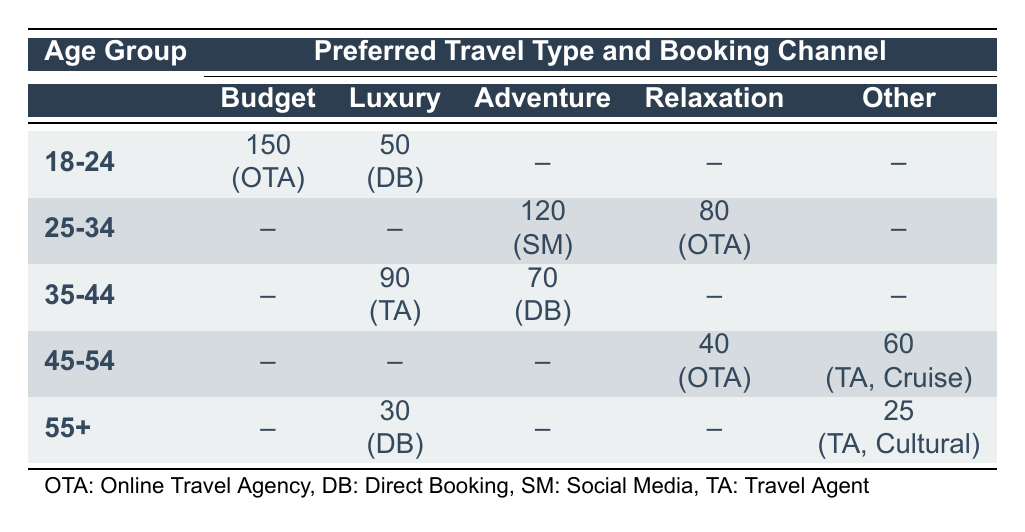What is the preferred travel type of the 18-24 age group using an online travel agency? The table shows that the 18-24 age group has a count of 150 for the Budget travel type under the Online Travel Agency booking channel.
Answer: Budget How many people aged 35-44 prefer Luxury travel and use a travel agent? The table indicates that for the 35-44 age group, 90 individuals prefer Luxury travel, and they book through a Travel Agent.
Answer: 90 Is there any age group that prefers Adventure travel through a Social Media channel? From the table, we see that the 25-34 age group prefers Adventure travel and books through Social Media, with a count of 120. Therefore, the answer is yes.
Answer: Yes What is the total count of people in the 45-54 age group who prefer Relaxation and Cruise travel? For the 45-54 age group, the table provides a count of 40 for Relaxation (Online Travel Agency) and 60 for Cruise (Travel Agent). The total is therefore 40 + 60 = 100.
Answer: 100 Which booking channel is most common for the Luxury travel type among these age groups? Reviewing the table shows that the Luxury travel type has counts of 50 (Direct Booking for 18-24), 90 (Travel Agent for 35-44), and 30 (Direct Booking for 55+). The highest count is 90, which corresponds to the Travel Agent channel for the 35-44 age group.
Answer: Travel Agent What percentage of the 25-34 age group prefers Relaxation travel compared to Adventure travel? For the 25-34 age group, there are 80 individuals who prefer Relaxation and 120 who prefer Adventure. The percentage of Relaxation travelers compared to Adventure travelers is (80/120) * 100 = 66.67%.
Answer: 66.67% Is the count of people preferring Cultural travel more than those preferring Budget travel among 55+? The table shows that 25 people aged 55+ prefer Cultural travel (Travel Agent) and no one in that age group prefers Budget travel. Therefore, 25 > 0 means the statement is true.
Answer: Yes Identify the booking channel with the highest count for the 18-24 age group and its preferred travel type. According to the table, the highest count of 150 for the 18-24 age group is for Budget travel booked through an Online Travel Agency.
Answer: Online Travel Agency, Budget What is the difference in counts between Relaxation and Adventure for the 35-44 age group? The table displays a count of 70 for Adventure (Direct Booking) in the 35-44 age group and no count for Relaxation. Therefore, the difference is 70 - 0 = 70.
Answer: 70 